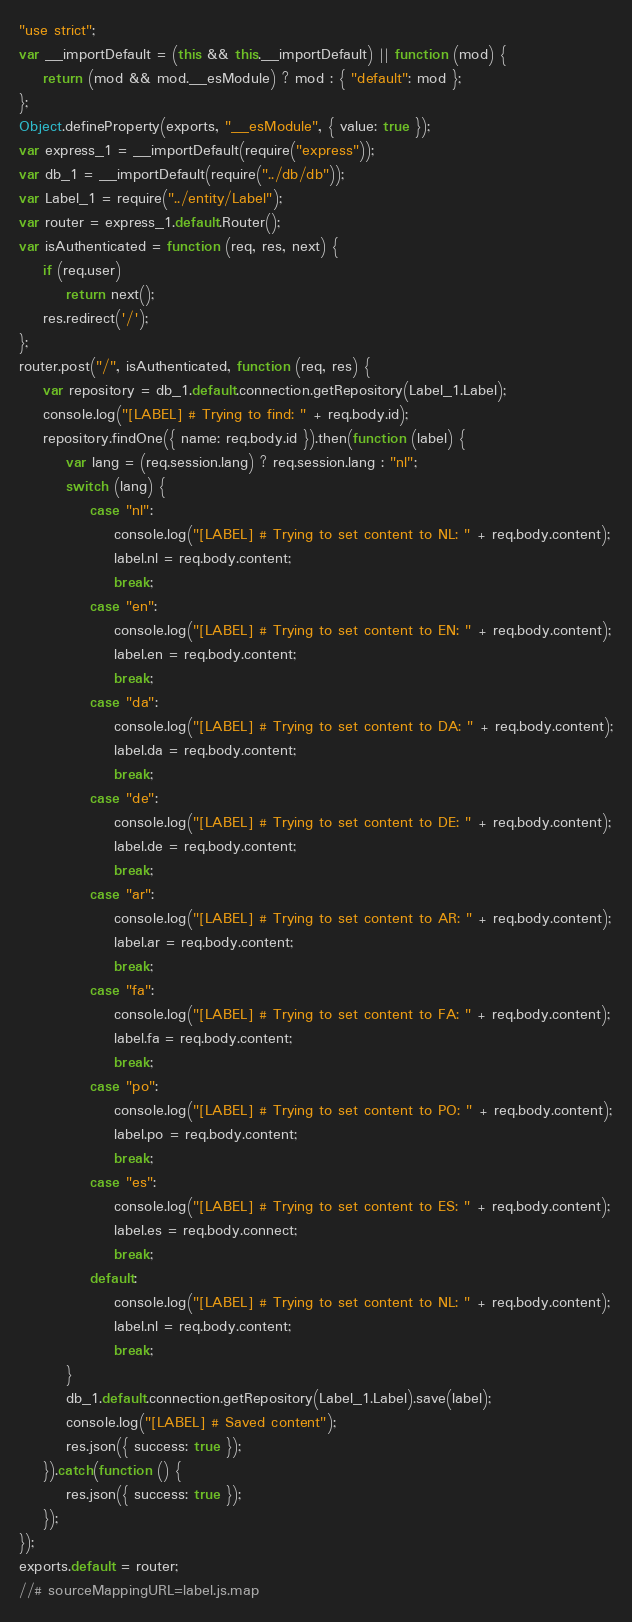Convert code to text. <code><loc_0><loc_0><loc_500><loc_500><_JavaScript_>"use strict";
var __importDefault = (this && this.__importDefault) || function (mod) {
    return (mod && mod.__esModule) ? mod : { "default": mod };
};
Object.defineProperty(exports, "__esModule", { value: true });
var express_1 = __importDefault(require("express"));
var db_1 = __importDefault(require("../db/db"));
var Label_1 = require("../entity/Label");
var router = express_1.default.Router();
var isAuthenticated = function (req, res, next) {
    if (req.user)
        return next();
    res.redirect('/');
};
router.post("/", isAuthenticated, function (req, res) {
    var repository = db_1.default.connection.getRepository(Label_1.Label);
    console.log("[LABEL] # Trying to find: " + req.body.id);
    repository.findOne({ name: req.body.id }).then(function (label) {
        var lang = (req.session.lang) ? req.session.lang : "nl";
        switch (lang) {
            case "nl":
                console.log("[LABEL] # Trying to set content to NL: " + req.body.content);
                label.nl = req.body.content;
                break;
            case "en":
                console.log("[LABEL] # Trying to set content to EN: " + req.body.content);
                label.en = req.body.content;
                break;
            case "da":
                console.log("[LABEL] # Trying to set content to DA: " + req.body.content);
                label.da = req.body.content;
                break;
            case "de":
                console.log("[LABEL] # Trying to set content to DE: " + req.body.content);
                label.de = req.body.content;
                break;
            case "ar":
                console.log("[LABEL] # Trying to set content to AR: " + req.body.content);
                label.ar = req.body.content;
                break;
            case "fa":
                console.log("[LABEL] # Trying to set content to FA: " + req.body.content);
                label.fa = req.body.content;
                break;
            case "po":
                console.log("[LABEL] # Trying to set content to PO: " + req.body.content);
                label.po = req.body.content;
                break;
            case "es":
                console.log("[LABEL] # Trying to set content to ES: " + req.body.content);
                label.es = req.body.connect;
                break;
            default:
                console.log("[LABEL] # Trying to set content to NL: " + req.body.content);
                label.nl = req.body.content;
                break;
        }
        db_1.default.connection.getRepository(Label_1.Label).save(label);
        console.log("[LABEL] # Saved content");
        res.json({ success: true });
    }).catch(function () {
        res.json({ success: true });
    });
});
exports.default = router;
//# sourceMappingURL=label.js.map</code> 